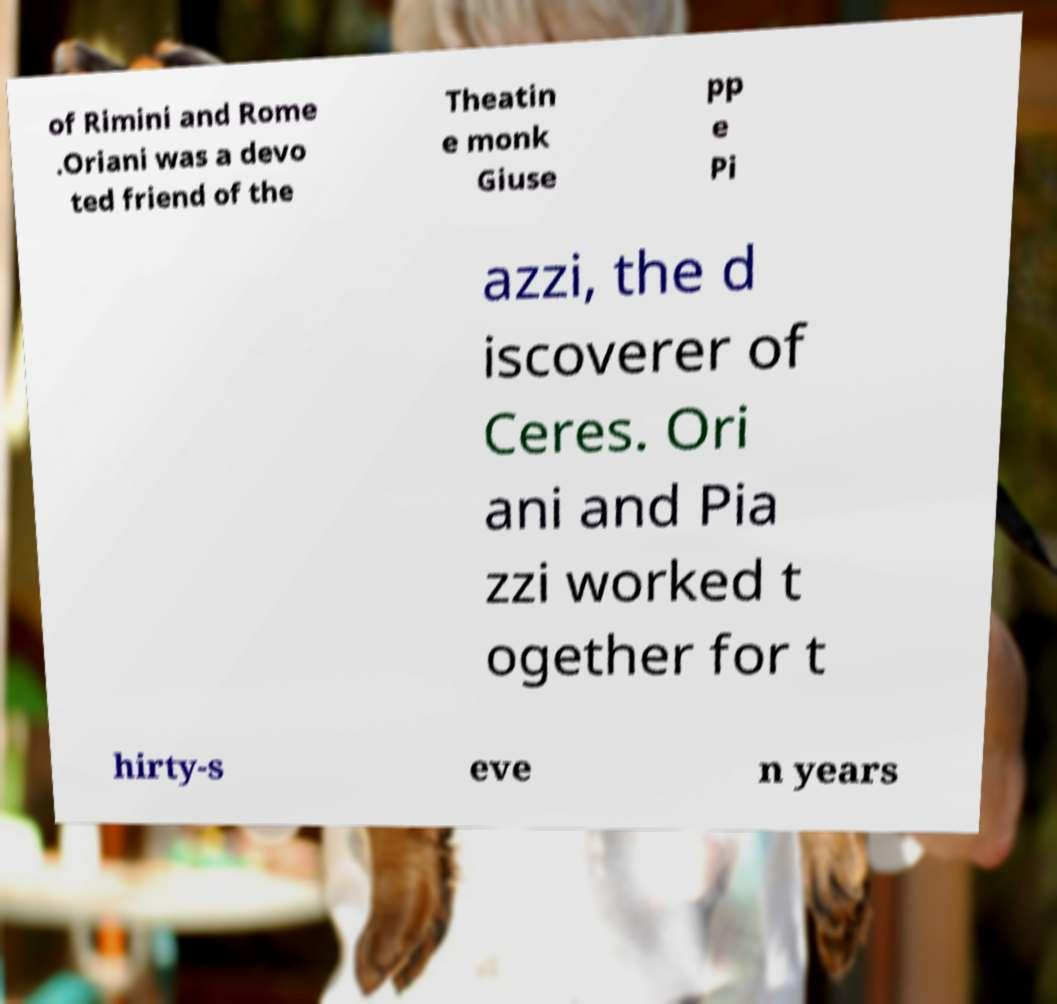I need the written content from this picture converted into text. Can you do that? of Rimini and Rome .Oriani was a devo ted friend of the Theatin e monk Giuse pp e Pi azzi, the d iscoverer of Ceres. Ori ani and Pia zzi worked t ogether for t hirty-s eve n years 